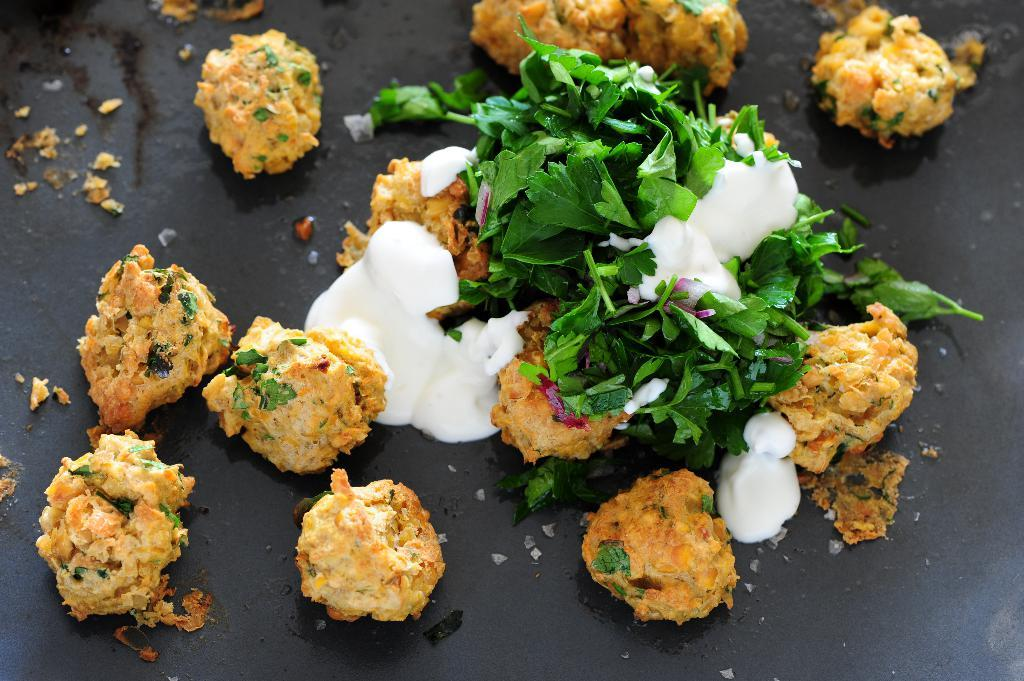What object is present in the image that can hold items? There is a tray in the image that can hold items. What type of food can be seen on the tray? The tray contains snacks. What accompanies the snacks on the tray? There is sauce on the tray. What type of writing can be seen on the snacks in the image? There is no writing visible on the snacks in the image. Are there any bears present in the image? There are no bears present in the image. 